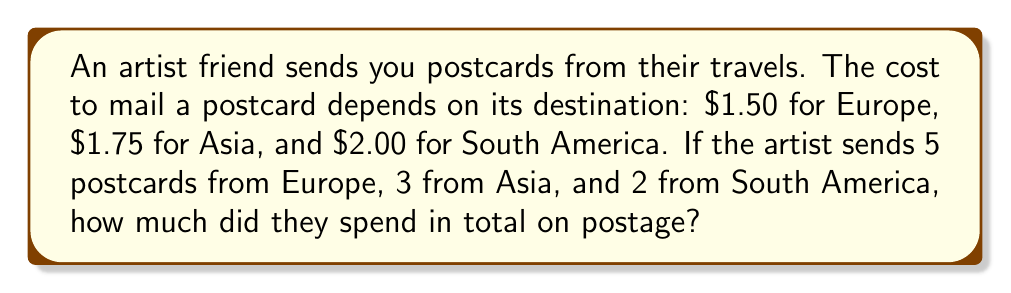Can you answer this question? Let's break this down step-by-step:

1. Calculate the cost for postcards from Europe:
   $$ 5 \text{ postcards} \times \$1.50 \text{ per postcard} = \$7.50 $$

2. Calculate the cost for postcards from Asia:
   $$ 3 \text{ postcards} \times \$1.75 \text{ per postcard} = \$5.25 $$

3. Calculate the cost for postcards from South America:
   $$ 2 \text{ postcards} \times \$2.00 \text{ per postcard} = \$4.00 $$

4. Sum up the total cost:
   $$ \text{Total} = \$7.50 + \$5.25 + \$4.00 = \$16.75 $$

Therefore, the artist spent a total of $\$16.75$ on postage for all the postcards.
Answer: $\$16.75$ 